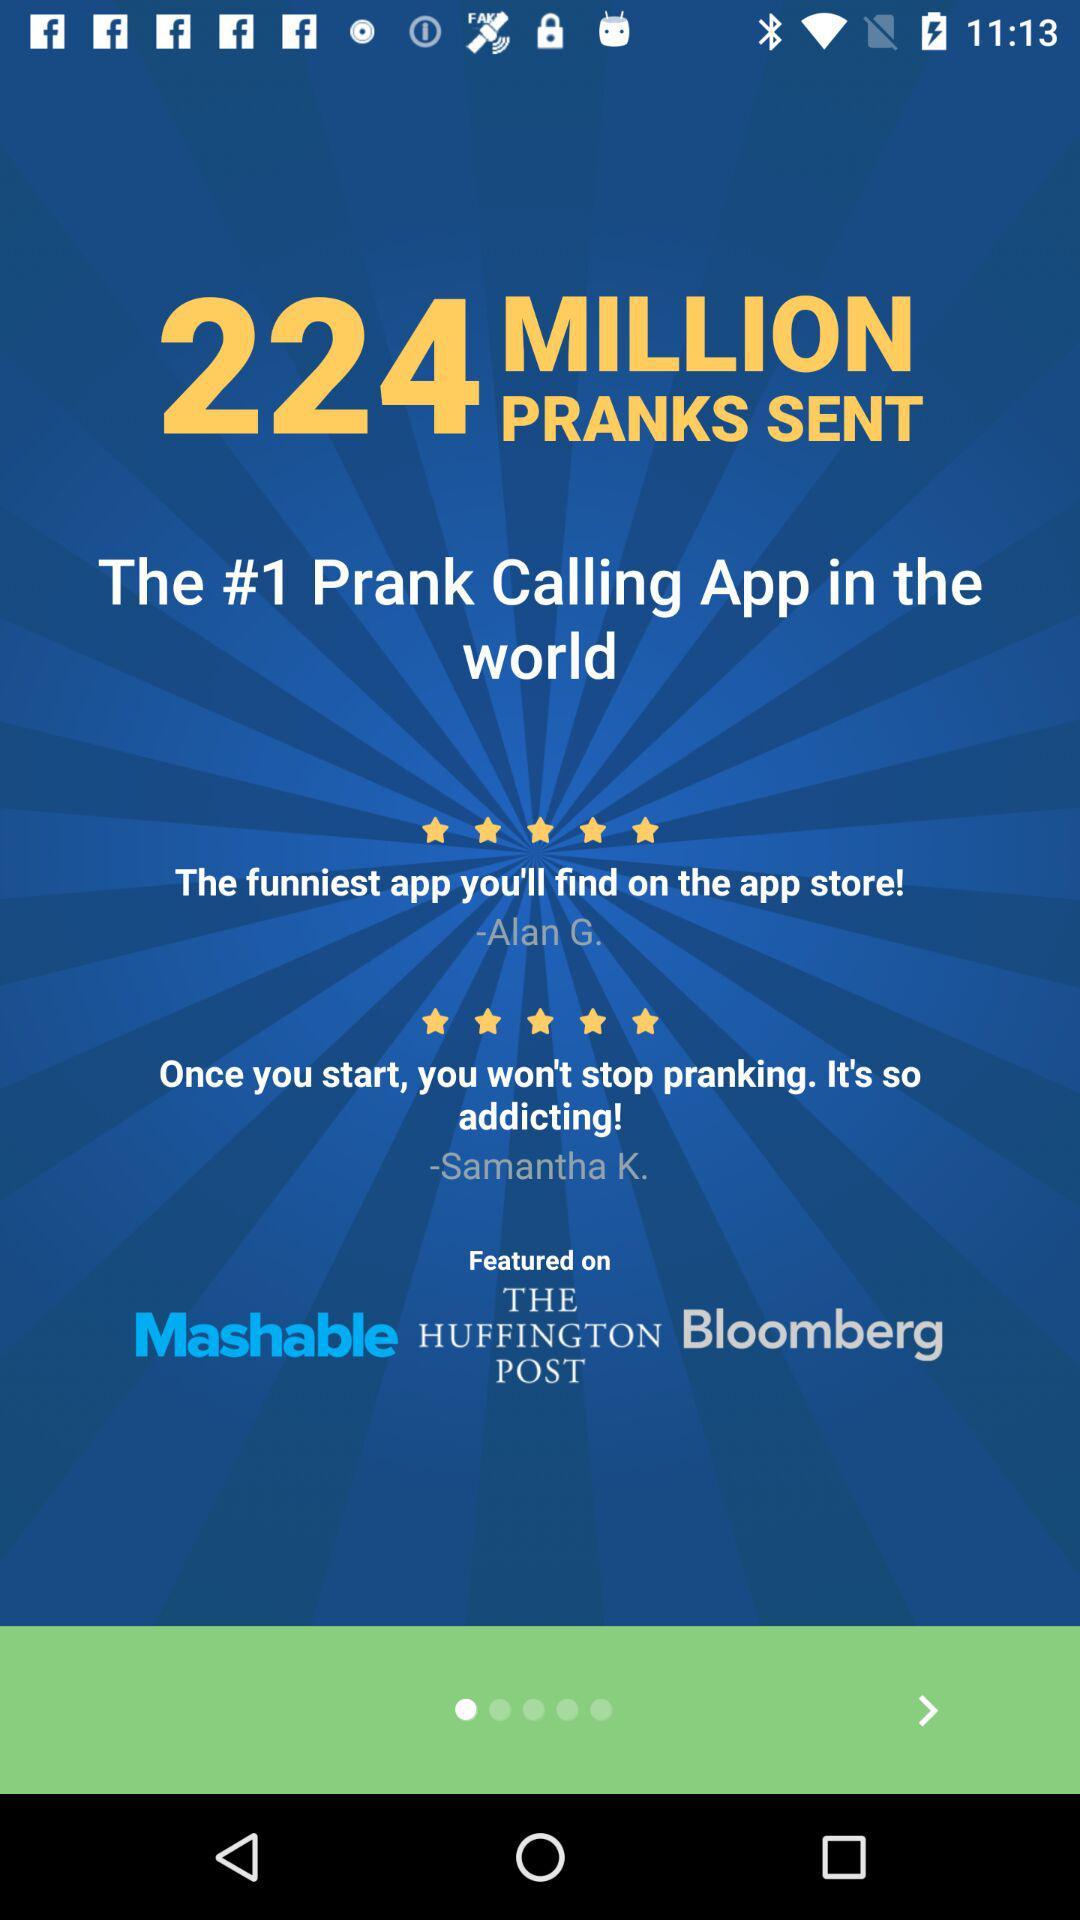What are the features of the application?
When the provided information is insufficient, respond with <no answer>. <no answer> 